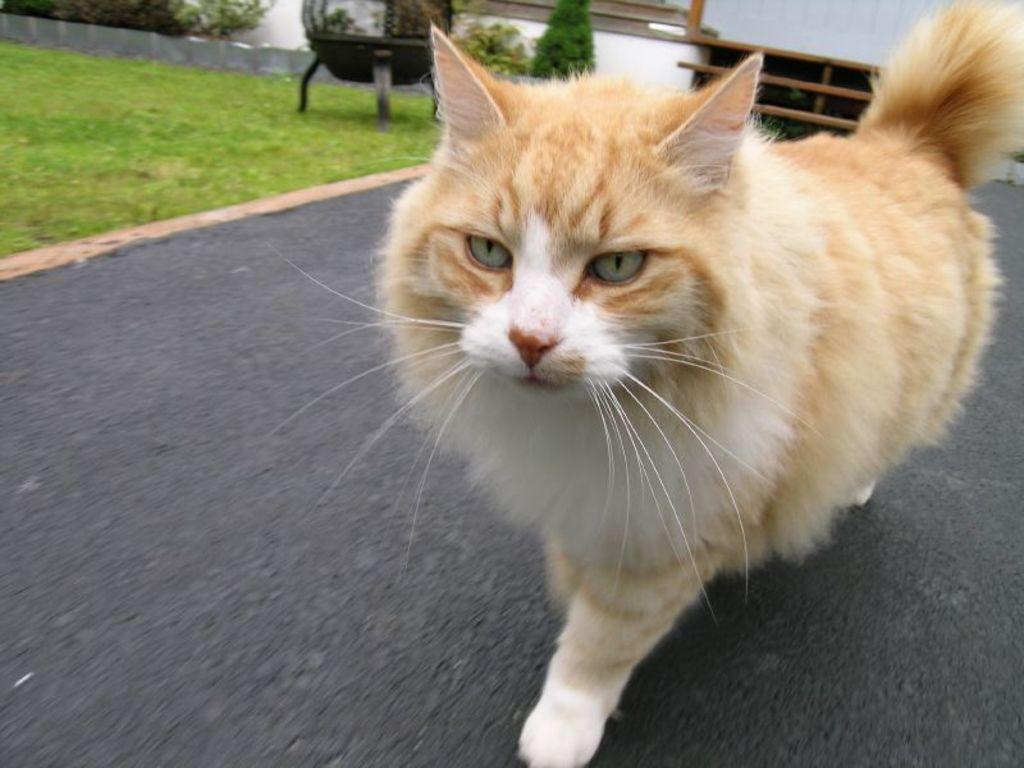What is walking on the road in the image? There is a cat walking on the road in the image. What can be seen on the grassland on the left side? There is an object on the grassland on the left side. What type of vegetation is visible in the image? There are plants visible in the image. Where is the rack located in the image? The rack is in the top right corner of the image. What type of structure is visible in the image? There is a wall visible in the image. What type of apple is being used for a science experiment in the image? There is no apple or science experiment present in the image. How is the coal being used in the image? There is no coal present in the image. 